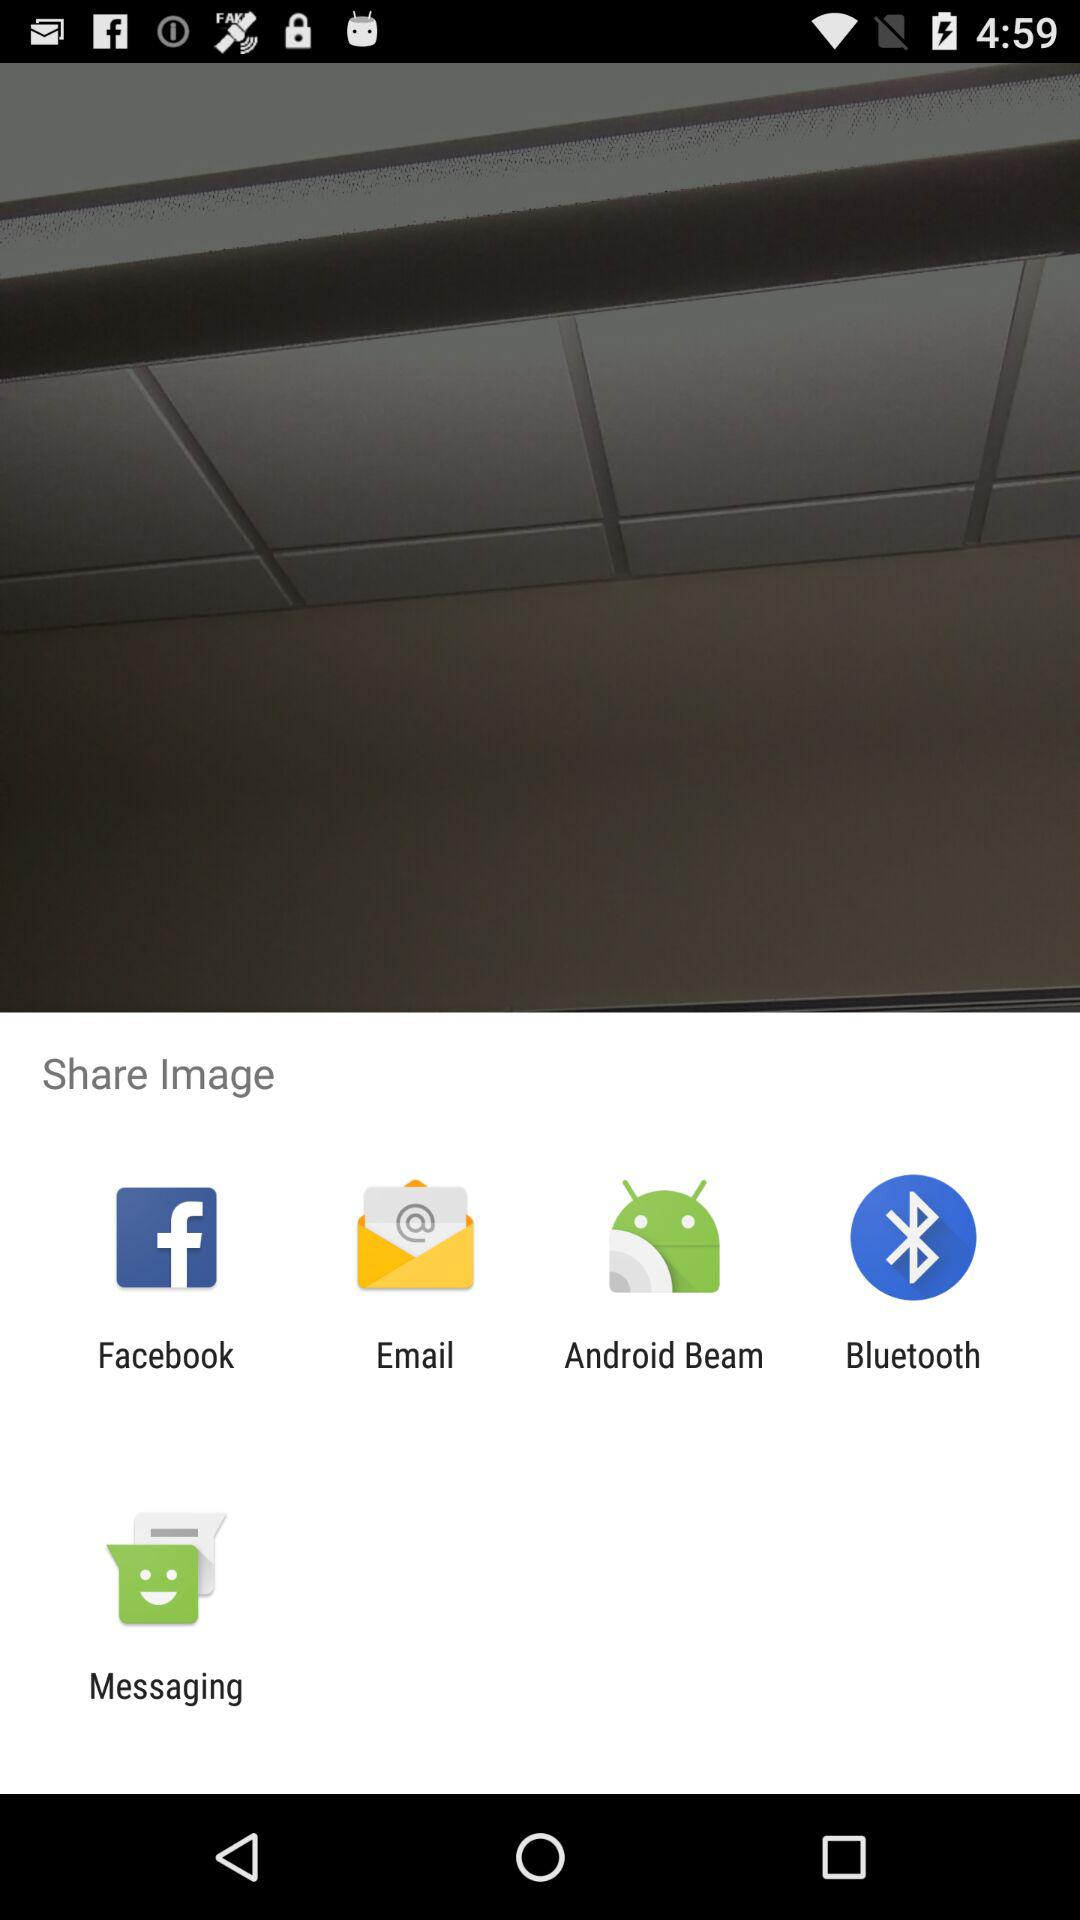Which application is used to share the image? The applications are "Facebook", "Email", "Android Beam", "Bluetooth" and "Messaging". 